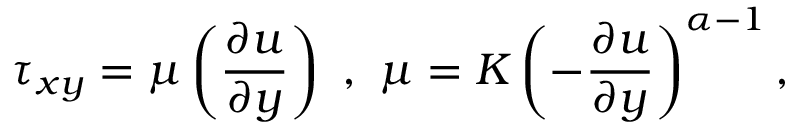<formula> <loc_0><loc_0><loc_500><loc_500>\tau _ { x y } = \mu \left ( \frac { \partial u } { \partial y } \right ) , \mu = K \left ( - \frac { \partial u } { \partial y } \right ) ^ { \alpha - 1 } ,</formula> 